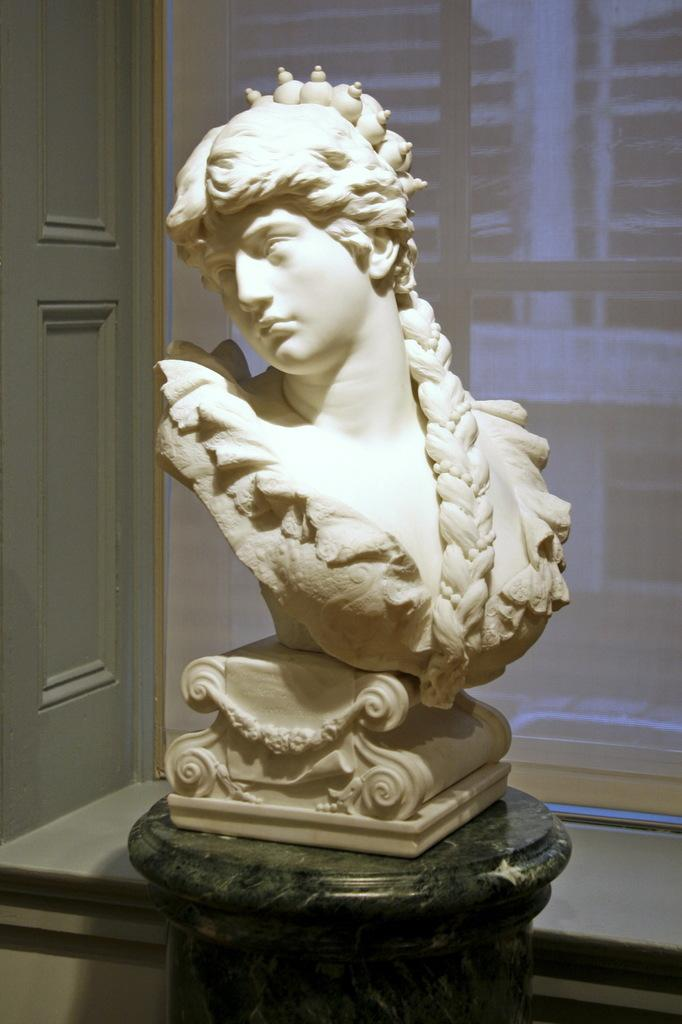What is the main subject of the image? There is a statue in the image. Where is the statue located? The statue is on a table. What architectural features can be seen in the image? There is a door and a window with a curtain in the image. What type of wax is used to create the crown on the statue's head? There is no crown on the statue's head in the image, and therefore no wax can be associated with it. Where is the dock located in the image? There is no dock present in the image. 